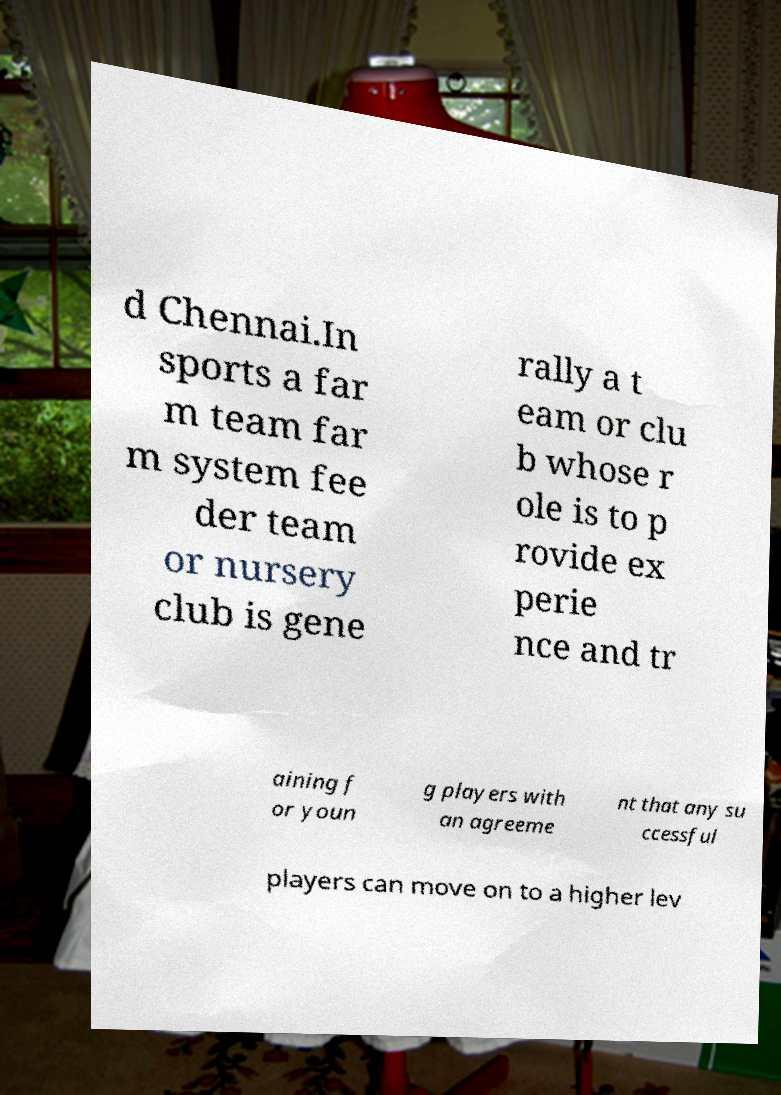For documentation purposes, I need the text within this image transcribed. Could you provide that? d Chennai.In sports a far m team far m system fee der team or nursery club is gene rally a t eam or clu b whose r ole is to p rovide ex perie nce and tr aining f or youn g players with an agreeme nt that any su ccessful players can move on to a higher lev 